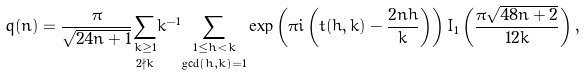Convert formula to latex. <formula><loc_0><loc_0><loc_500><loc_500>q ( n ) = \frac { \pi } { \sqrt { 2 4 n + 1 } } \underset { 2 \nmid k } { \sum _ { k \geq 1 } } k ^ { - 1 } \underset { \gcd ( h , k ) = 1 } { \sum _ { 1 \leq h < k } } \exp \left ( { \pi i \left ( t ( h , k ) - \frac { 2 n h } { k } \right ) } \right ) I _ { 1 } \left ( \frac { \pi \sqrt { 4 8 n + 2 } } { 1 2 k } \right ) ,</formula> 